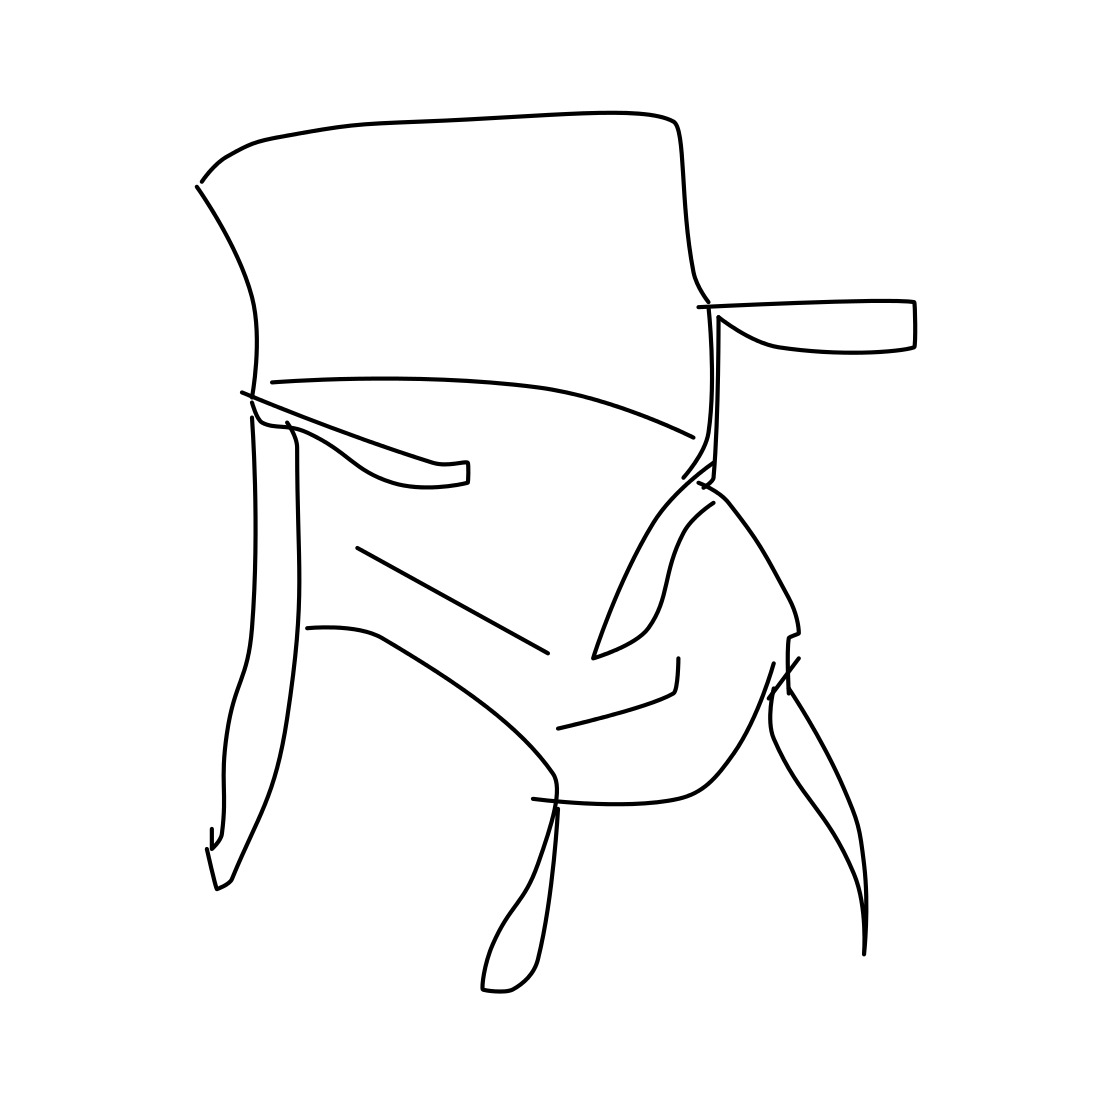In the scene, is a tree in it? I've examined the image carefully, and there's no tree present. It's a minimalist line drawing of what appears to be an abstract form or possibly a stylized representation of a chair or piece of furniture. 